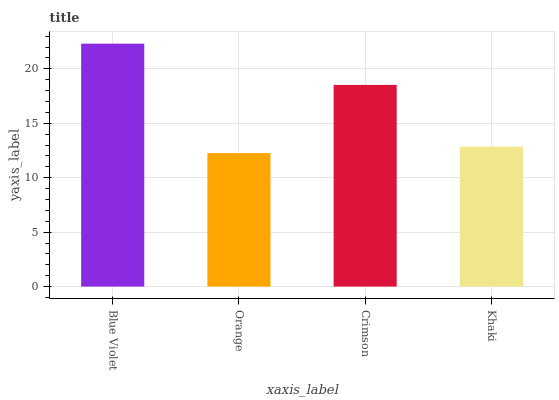Is Orange the minimum?
Answer yes or no. Yes. Is Blue Violet the maximum?
Answer yes or no. Yes. Is Crimson the minimum?
Answer yes or no. No. Is Crimson the maximum?
Answer yes or no. No. Is Crimson greater than Orange?
Answer yes or no. Yes. Is Orange less than Crimson?
Answer yes or no. Yes. Is Orange greater than Crimson?
Answer yes or no. No. Is Crimson less than Orange?
Answer yes or no. No. Is Crimson the high median?
Answer yes or no. Yes. Is Khaki the low median?
Answer yes or no. Yes. Is Orange the high median?
Answer yes or no. No. Is Blue Violet the low median?
Answer yes or no. No. 